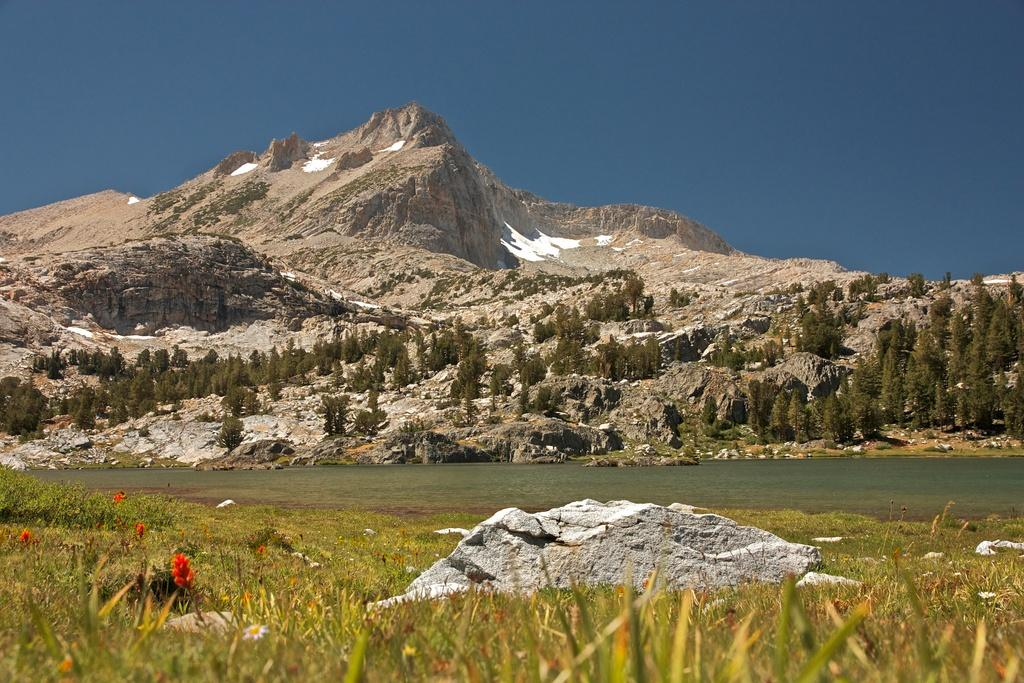What type of plants can be seen in the image? There are flowers and greenery in the image. What is located at the bottom side of the image? There is a stone at the bottom side of the image. What can be seen in the center of the image? There appears to be water in the center of the image. What type of vegetation is visible in the background of the image? There are trees in the background of the image. What type of landscape feature is visible in the background of the image? There are mountains in the background of the image. What else is visible in the background of the image? The sky is visible in the background of the image. How many potatoes are hidden among the flowers in the image? There are no potatoes present in the image; it features flowers, greenery, water, trees, mountains, and the sky. What type of twig can be seen supporting the flowers in the image? There is no twig present in the image; the flowers are not supported by any visible twig. 